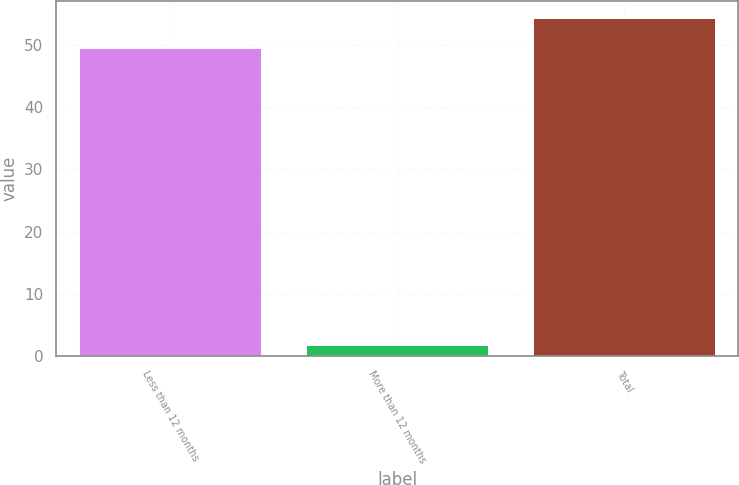Convert chart to OTSL. <chart><loc_0><loc_0><loc_500><loc_500><bar_chart><fcel>Less than 12 months<fcel>More than 12 months<fcel>Total<nl><fcel>49.4<fcel>1.8<fcel>54.34<nl></chart> 